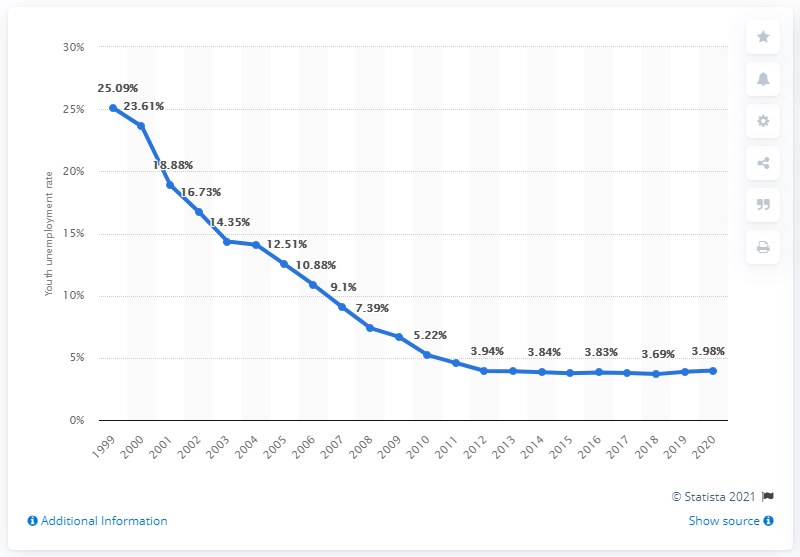Give some essential details in this illustration. The youth unemployment rate in Kazakhstan was 3.98% in 2020. 